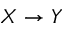Convert formula to latex. <formula><loc_0><loc_0><loc_500><loc_500>X \to Y</formula> 